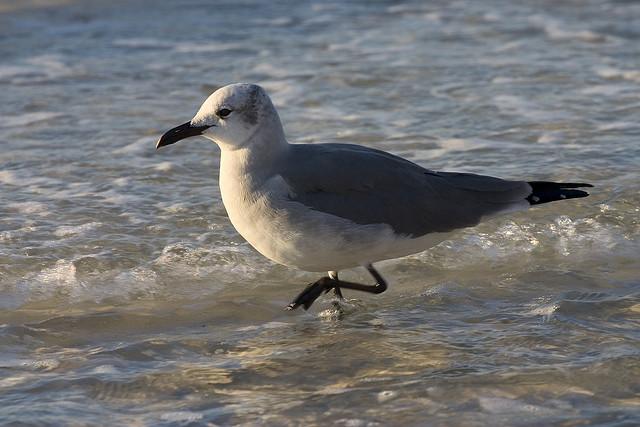How many feet are in the water?
Answer briefly. 1. What body of water is the bird walking in?
Keep it brief. Ocean. Is this photo outdoors?
Keep it brief. Yes. 